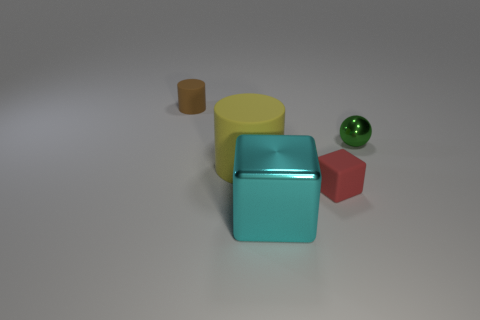How would you describe the lighting in this scene? The lighting in the scene is soft and diffused, likely coming from a source overhead. There are subtle shadows under the objects, suggesting the light direction is somewhat angled, providing soft illumination without harsh contrasts.  What time of day might it represent? Since the setup appears to be an indoor studio with controlled lighting, it doesn't directly represent any specific time of day. However, the quality of light resembles natural daylight, maybe resembling early afternoon when the light is bright but not as intense as midday. 